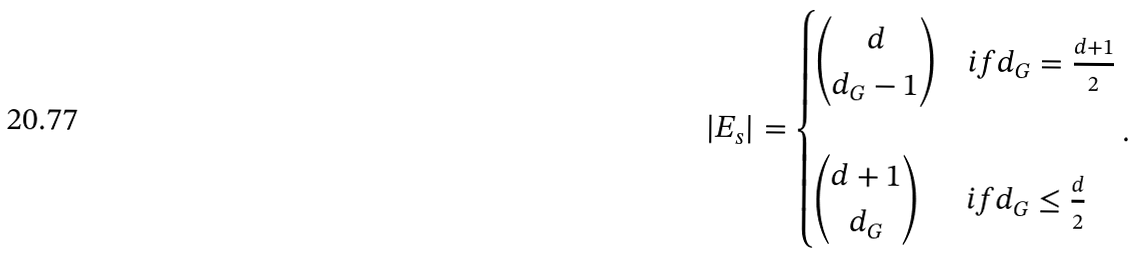Convert formula to latex. <formula><loc_0><loc_0><loc_500><loc_500>| E _ { s } | = \begin{cases} \begin{pmatrix} d \\ d _ { G } - 1 \end{pmatrix} & i f d _ { G } = \frac { d + 1 } { 2 } \\ \\ \begin{pmatrix} d + 1 \\ d _ { G } \end{pmatrix} & i f d _ { G } \leq \frac { d } { 2 } \end{cases} .</formula> 